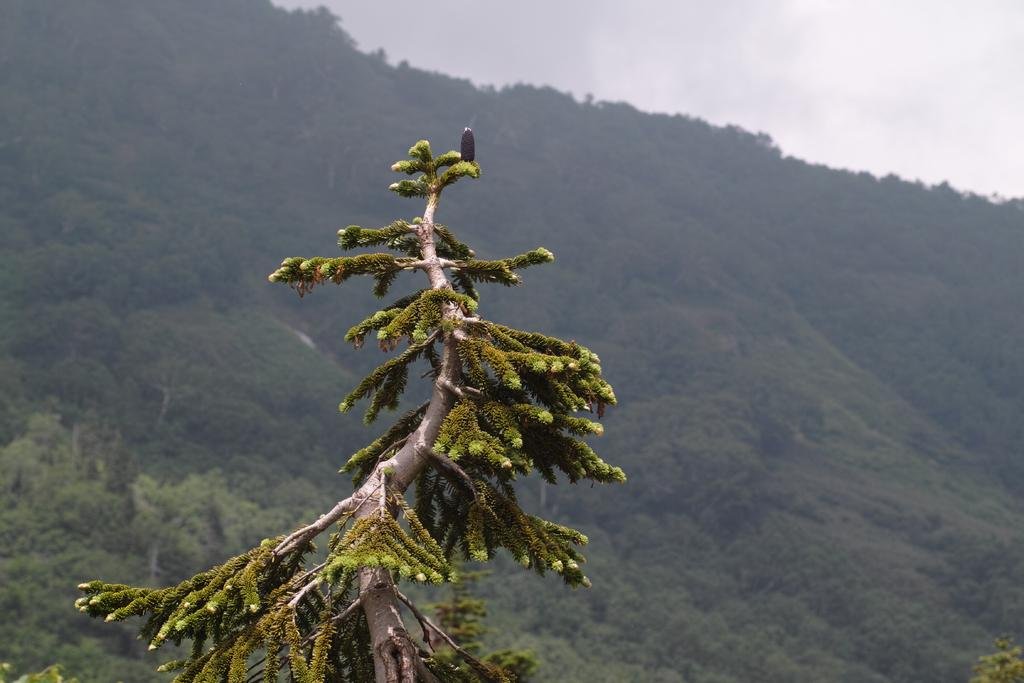What type of vegetation can be seen in the image? There are trees in the image. What geographical feature is visible in the background of the image? There is a mountain visible in the background of the image. What part of the natural environment is visible in the image? The sky is visible in the background of the image. Can you see a gun hanging from one of the trees in the image? There is no gun present in the image; it only features trees and a mountain in the background. Is there a hook attached to the mountain in the image? There is no hook attached to the mountain in the image. 